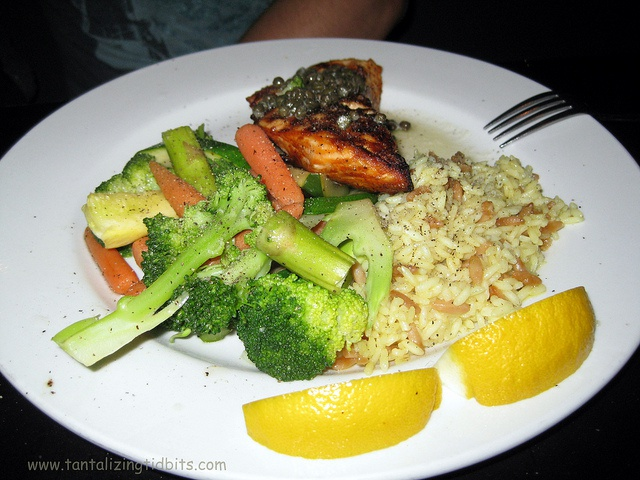Describe the objects in this image and their specific colors. I can see broccoli in black, khaki, darkgreen, and olive tones, people in black, maroon, and darkblue tones, carrot in black, red, salmon, and tan tones, fork in black, gray, darkgray, and maroon tones, and broccoli in black, olive, and darkgreen tones in this image. 